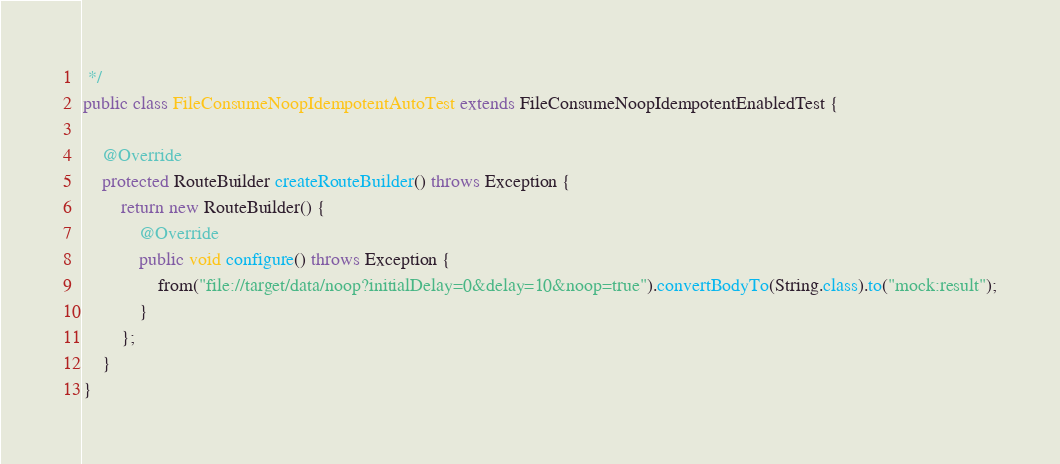<code> <loc_0><loc_0><loc_500><loc_500><_Java_> */
public class FileConsumeNoopIdempotentAutoTest extends FileConsumeNoopIdempotentEnabledTest {

    @Override
    protected RouteBuilder createRouteBuilder() throws Exception {
        return new RouteBuilder() {
            @Override
            public void configure() throws Exception {
                from("file://target/data/noop?initialDelay=0&delay=10&noop=true").convertBodyTo(String.class).to("mock:result");
            }
        };
    }
}</code> 